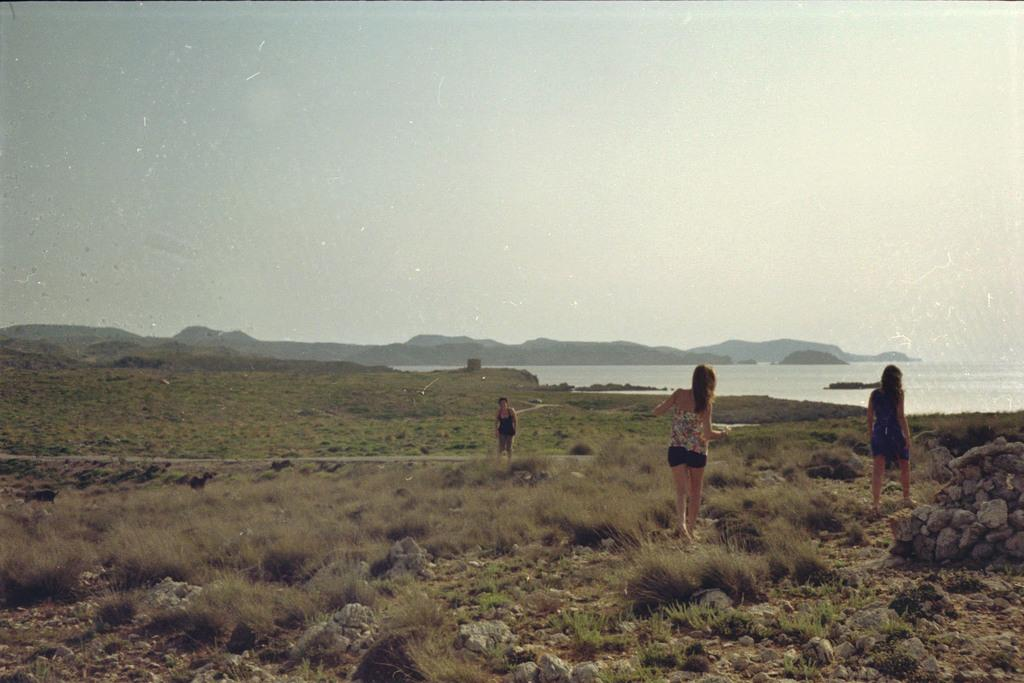What type of terrain is visible at the bottom of the image? There is grass and stones at the bottom of the image. How many ladies are present in the image? There are three ladies in the image. What can be seen in the distance in the image? There are mountains in the background of the image, along with water and the sky. What type of jelly is being used to create the mountains in the image? The mountains in the image are not created with jelly; they are natural landforms. Can you tell me what the dad of one of the ladies is doing in the image? There is no dad present in the image, as it only features three ladies. 